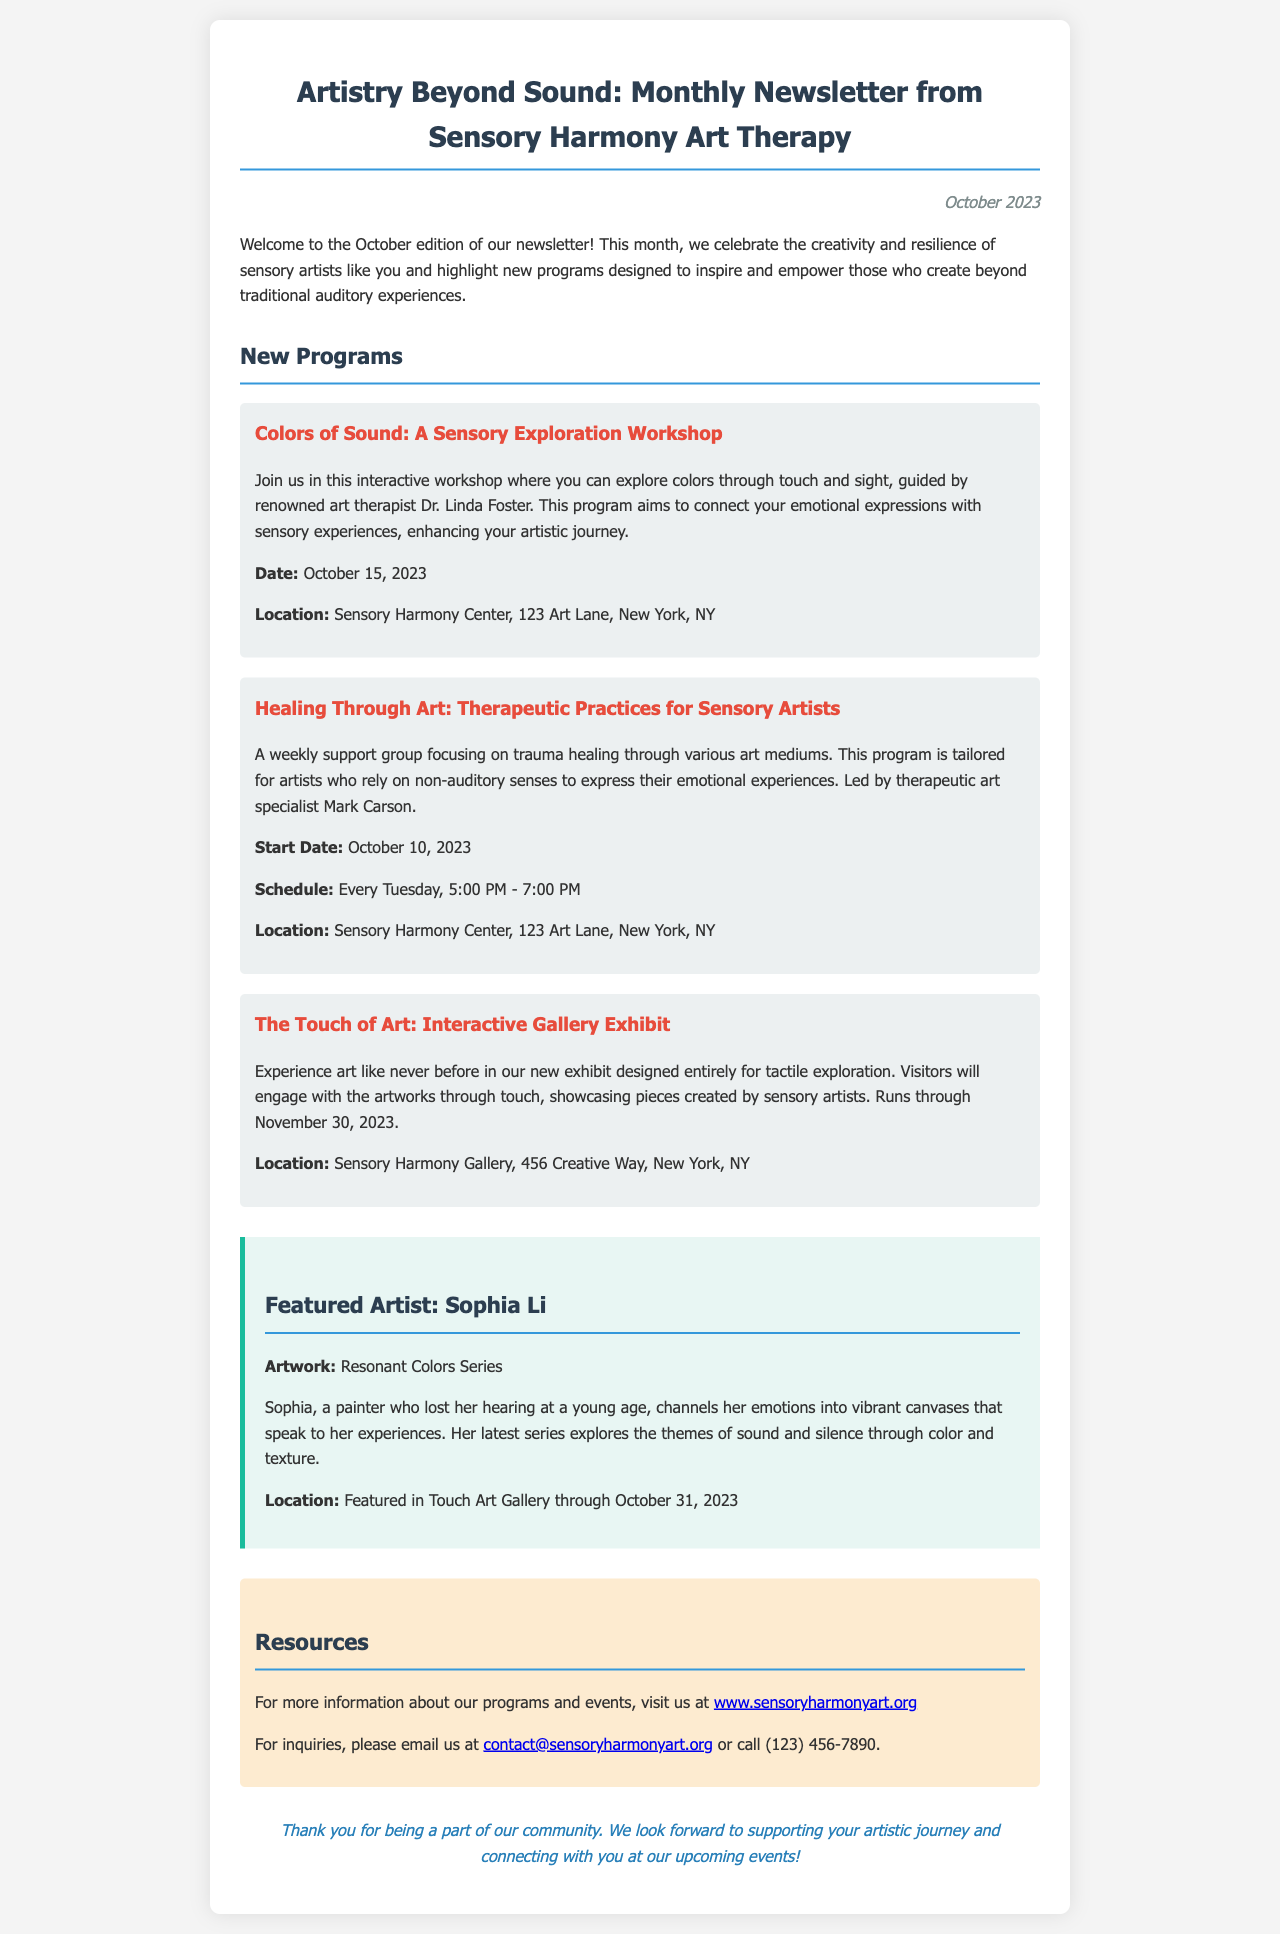What is the title of the newsletter? The title of the newsletter is mentioned at the beginning of the document.
Answer: Artistry Beyond Sound: Monthly Newsletter from Sensory Harmony Art Therapy What is the date of the newsletter? The date of the newsletter is specified in the document.
Answer: October 2023 What is the name of the first program listed? The first program is the one highlighted under New Programs.
Answer: Colors of Sound: A Sensory Exploration Workshop Who is leading the Healing Through Art program? The leader of the Healing Through Art program is mentioned in the program description.
Answer: Mark Carson What is the location of the Touch of Art exhibit? The location of the exhibit is stated in the document.
Answer: Sensory Harmony Gallery, 456 Creative Way, New York, NY What is the artwork title of the featured artist? The title of the artwork is specified in the section about the featured artist.
Answer: Resonant Colors Series How many weeks does the Healing Through Art program run? The Healing Through Art program runs every Tuesday, which indicates a recurring schedule.
Answer: Ongoing (every Tuesday) What is the last date for the Touch of Art exhibit? The ending date of the exhibit is provided in the document.
Answer: November 30, 2023 What is the contact email provided for inquiries? The email for inquiries is clearly stated in the resources section.
Answer: contact@sensoryharmonyart.org 